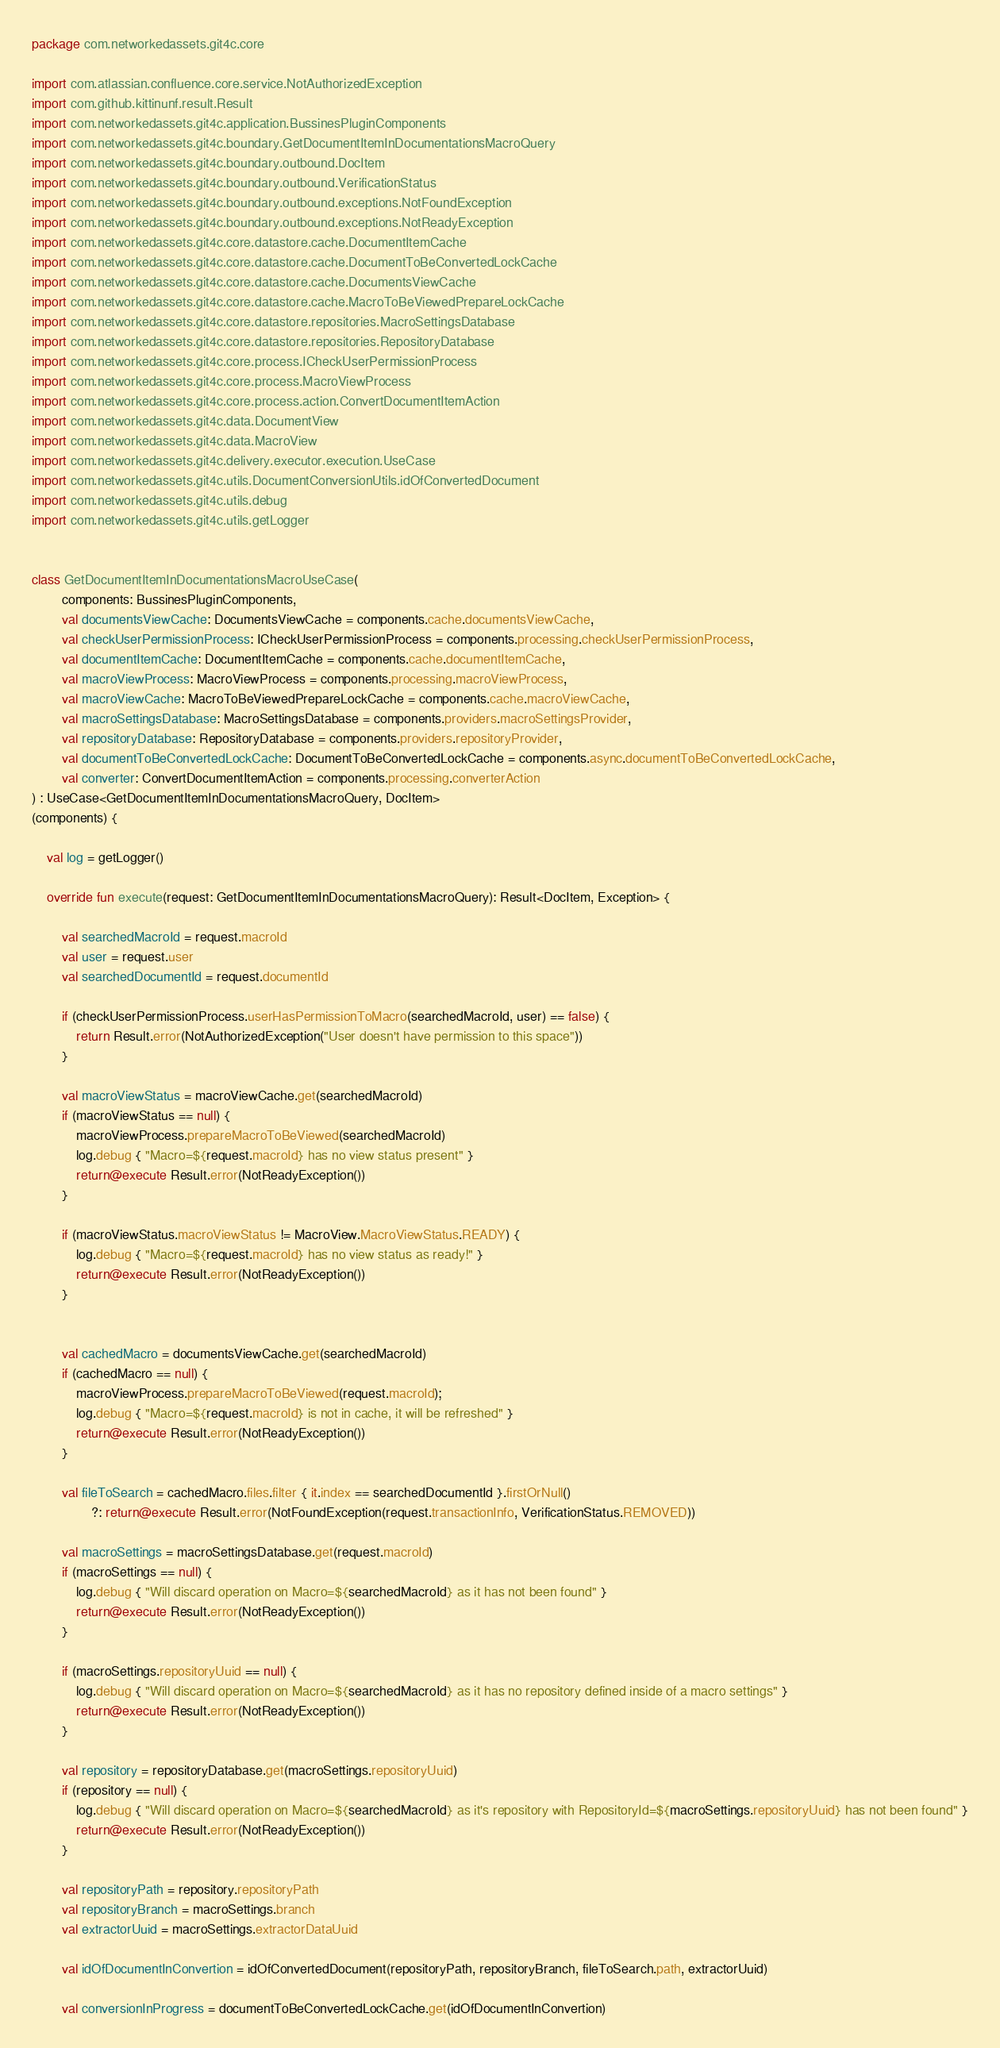Convert code to text. <code><loc_0><loc_0><loc_500><loc_500><_Kotlin_>package com.networkedassets.git4c.core

import com.atlassian.confluence.core.service.NotAuthorizedException
import com.github.kittinunf.result.Result
import com.networkedassets.git4c.application.BussinesPluginComponents
import com.networkedassets.git4c.boundary.GetDocumentItemInDocumentationsMacroQuery
import com.networkedassets.git4c.boundary.outbound.DocItem
import com.networkedassets.git4c.boundary.outbound.VerificationStatus
import com.networkedassets.git4c.boundary.outbound.exceptions.NotFoundException
import com.networkedassets.git4c.boundary.outbound.exceptions.NotReadyException
import com.networkedassets.git4c.core.datastore.cache.DocumentItemCache
import com.networkedassets.git4c.core.datastore.cache.DocumentToBeConvertedLockCache
import com.networkedassets.git4c.core.datastore.cache.DocumentsViewCache
import com.networkedassets.git4c.core.datastore.cache.MacroToBeViewedPrepareLockCache
import com.networkedassets.git4c.core.datastore.repositories.MacroSettingsDatabase
import com.networkedassets.git4c.core.datastore.repositories.RepositoryDatabase
import com.networkedassets.git4c.core.process.ICheckUserPermissionProcess
import com.networkedassets.git4c.core.process.MacroViewProcess
import com.networkedassets.git4c.core.process.action.ConvertDocumentItemAction
import com.networkedassets.git4c.data.DocumentView
import com.networkedassets.git4c.data.MacroView
import com.networkedassets.git4c.delivery.executor.execution.UseCase
import com.networkedassets.git4c.utils.DocumentConversionUtils.idOfConvertedDocument
import com.networkedassets.git4c.utils.debug
import com.networkedassets.git4c.utils.getLogger


class GetDocumentItemInDocumentationsMacroUseCase(
        components: BussinesPluginComponents,
        val documentsViewCache: DocumentsViewCache = components.cache.documentsViewCache,
        val checkUserPermissionProcess: ICheckUserPermissionProcess = components.processing.checkUserPermissionProcess,
        val documentItemCache: DocumentItemCache = components.cache.documentItemCache,
        val macroViewProcess: MacroViewProcess = components.processing.macroViewProcess,
        val macroViewCache: MacroToBeViewedPrepareLockCache = components.cache.macroViewCache,
        val macroSettingsDatabase: MacroSettingsDatabase = components.providers.macroSettingsProvider,
        val repositoryDatabase: RepositoryDatabase = components.providers.repositoryProvider,
        val documentToBeConvertedLockCache: DocumentToBeConvertedLockCache = components.async.documentToBeConvertedLockCache,
        val converter: ConvertDocumentItemAction = components.processing.converterAction
) : UseCase<GetDocumentItemInDocumentationsMacroQuery, DocItem>
(components) {

    val log = getLogger()

    override fun execute(request: GetDocumentItemInDocumentationsMacroQuery): Result<DocItem, Exception> {

        val searchedMacroId = request.macroId
        val user = request.user
        val searchedDocumentId = request.documentId

        if (checkUserPermissionProcess.userHasPermissionToMacro(searchedMacroId, user) == false) {
            return Result.error(NotAuthorizedException("User doesn't have permission to this space"))
        }

        val macroViewStatus = macroViewCache.get(searchedMacroId)
        if (macroViewStatus == null) {
            macroViewProcess.prepareMacroToBeViewed(searchedMacroId)
            log.debug { "Macro=${request.macroId} has no view status present" }
            return@execute Result.error(NotReadyException())
        }

        if (macroViewStatus.macroViewStatus != MacroView.MacroViewStatus.READY) {
            log.debug { "Macro=${request.macroId} has no view status as ready!" }
            return@execute Result.error(NotReadyException())
        }


        val cachedMacro = documentsViewCache.get(searchedMacroId)
        if (cachedMacro == null) {
            macroViewProcess.prepareMacroToBeViewed(request.macroId);
            log.debug { "Macro=${request.macroId} is not in cache, it will be refreshed" }
            return@execute Result.error(NotReadyException())
        }

        val fileToSearch = cachedMacro.files.filter { it.index == searchedDocumentId }.firstOrNull()
                ?: return@execute Result.error(NotFoundException(request.transactionInfo, VerificationStatus.REMOVED))

        val macroSettings = macroSettingsDatabase.get(request.macroId)
        if (macroSettings == null) {
            log.debug { "Will discard operation on Macro=${searchedMacroId} as it has not been found" }
            return@execute Result.error(NotReadyException())
        }

        if (macroSettings.repositoryUuid == null) {
            log.debug { "Will discard operation on Macro=${searchedMacroId} as it has no repository defined inside of a macro settings" }
            return@execute Result.error(NotReadyException())
        }

        val repository = repositoryDatabase.get(macroSettings.repositoryUuid)
        if (repository == null) {
            log.debug { "Will discard operation on Macro=${searchedMacroId} as it's repository with RepositoryId=${macroSettings.repositoryUuid} has not been found" }
            return@execute Result.error(NotReadyException())
        }

        val repositoryPath = repository.repositoryPath
        val repositoryBranch = macroSettings.branch
        val extractorUuid = macroSettings.extractorDataUuid

        val idOfDocumentInConvertion = idOfConvertedDocument(repositoryPath, repositoryBranch, fileToSearch.path, extractorUuid)

        val conversionInProgress = documentToBeConvertedLockCache.get(idOfDocumentInConvertion)
</code> 